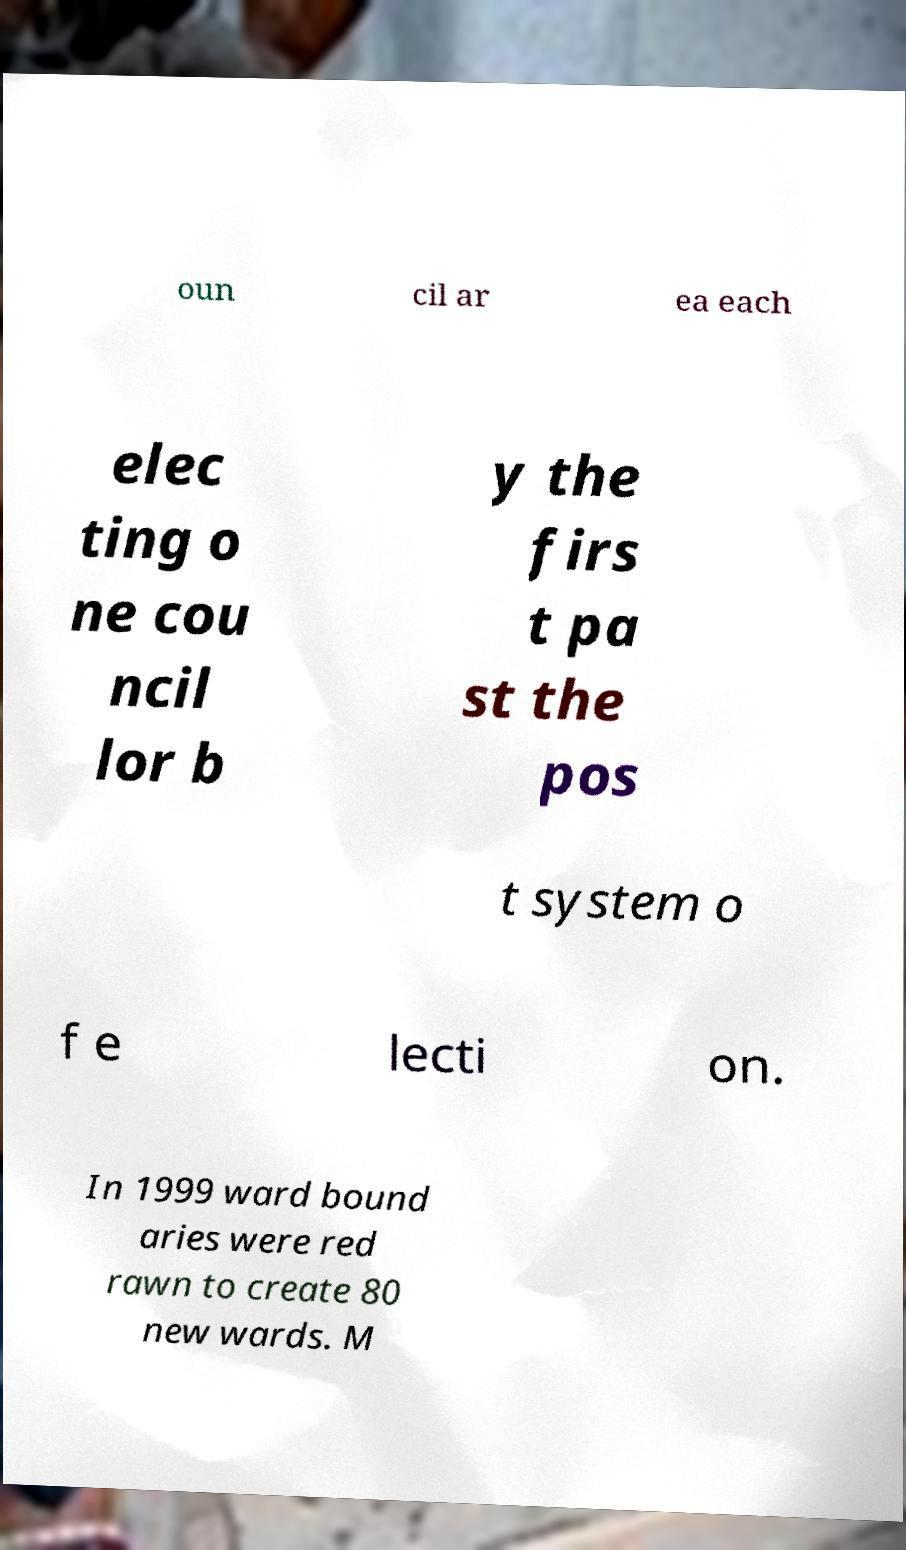Can you read and provide the text displayed in the image?This photo seems to have some interesting text. Can you extract and type it out for me? oun cil ar ea each elec ting o ne cou ncil lor b y the firs t pa st the pos t system o f e lecti on. In 1999 ward bound aries were red rawn to create 80 new wards. M 